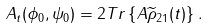<formula> <loc_0><loc_0><loc_500><loc_500>A _ { t } ( \phi _ { 0 } , \psi _ { 0 } ) = 2 T r \left \{ A \widetilde { \rho } _ { 2 1 } ( t ) \right \} .</formula> 